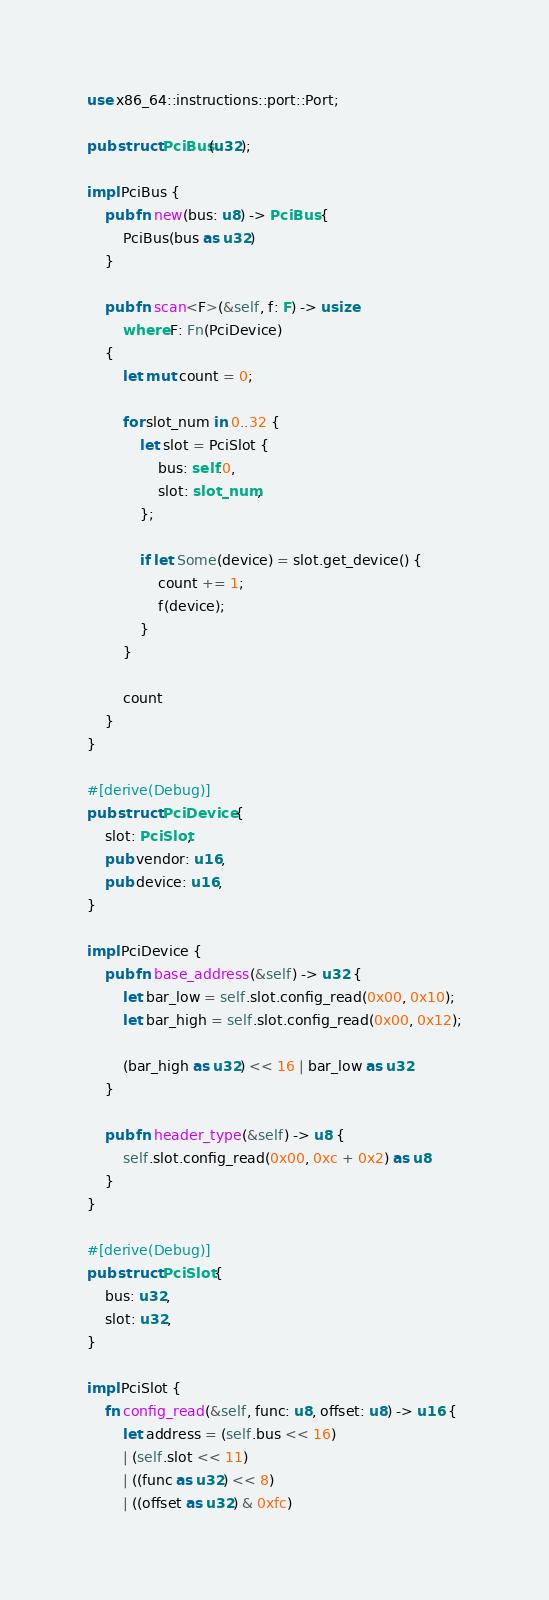<code> <loc_0><loc_0><loc_500><loc_500><_Rust_>use x86_64::instructions::port::Port;

pub struct PciBus(u32);

impl PciBus {
    pub fn new(bus: u8) -> PciBus {
        PciBus(bus as u32)
    }

    pub fn scan<F>(&self, f: F) -> usize
        where F: Fn(PciDevice)
    {
        let mut count = 0;
        
        for slot_num in 0..32 {
            let slot = PciSlot {
                bus: self.0,
                slot: slot_num,
            };

            if let Some(device) = slot.get_device() {
                count += 1;
                f(device);
            }
        }

        count
    }
}

#[derive(Debug)]
pub struct PciDevice {
    slot: PciSlot,
    pub vendor: u16,
    pub device: u16,
}

impl PciDevice {
    pub fn base_address(&self) -> u32 {
        let bar_low = self.slot.config_read(0x00, 0x10);
        let bar_high = self.slot.config_read(0x00, 0x12);

        (bar_high as u32) << 16 | bar_low as u32
    }

    pub fn header_type(&self) -> u8 {
        self.slot.config_read(0x00, 0xc + 0x2) as u8
    }
}

#[derive(Debug)]
pub struct PciSlot {
    bus: u32,
    slot: u32,
}

impl PciSlot {
    fn config_read(&self, func: u8, offset: u8) -> u16 {
        let address = (self.bus << 16)
        | (self.slot << 11)
        | ((func as u32) << 8)
        | ((offset as u32) & 0xfc)</code> 